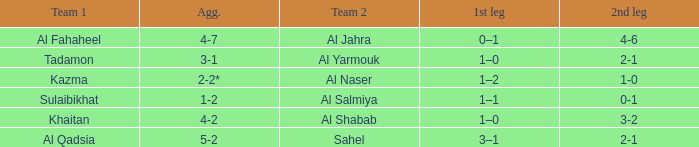What is the name of Team 2 with a Team 1 of Al Qadsia? Sahel. 